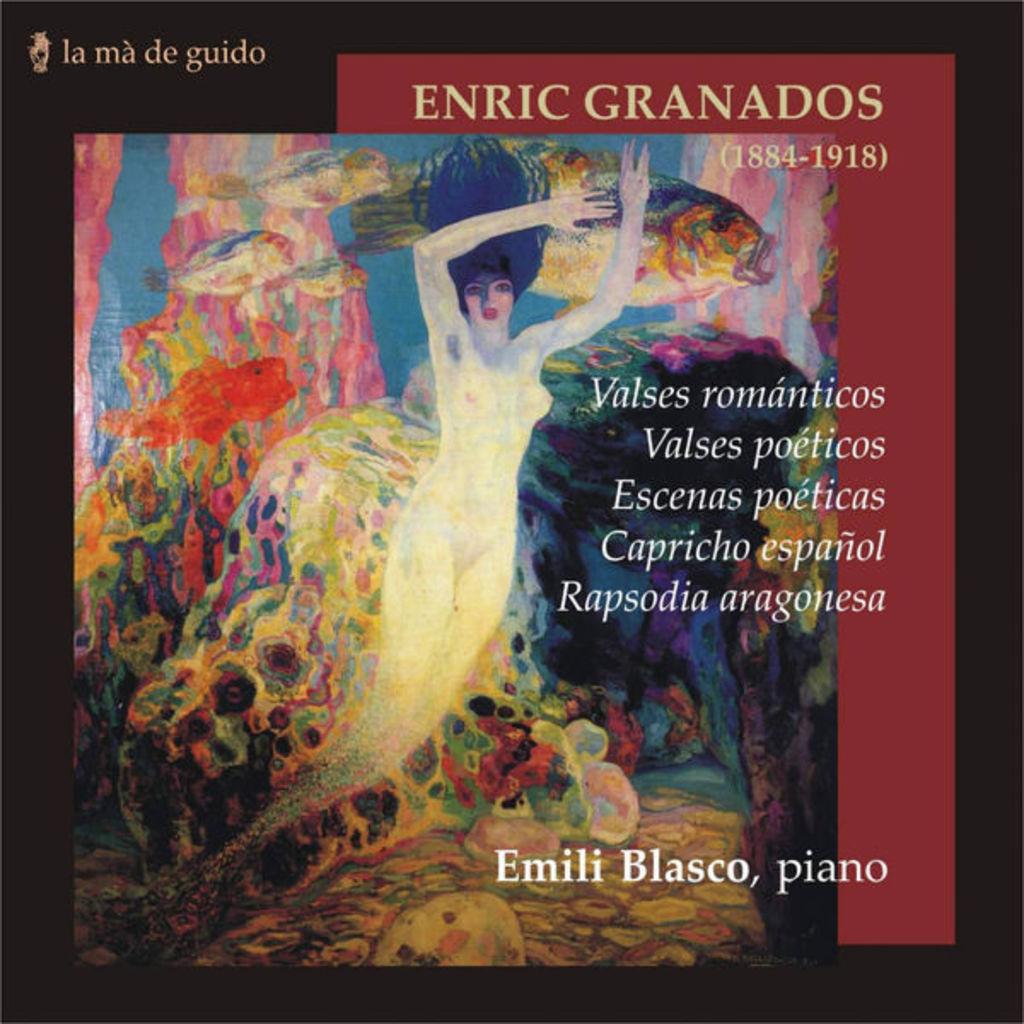Who plays the piano?
Offer a very short reply. Emili blasco. What years are these through?
Your answer should be very brief. 1884-1918. 